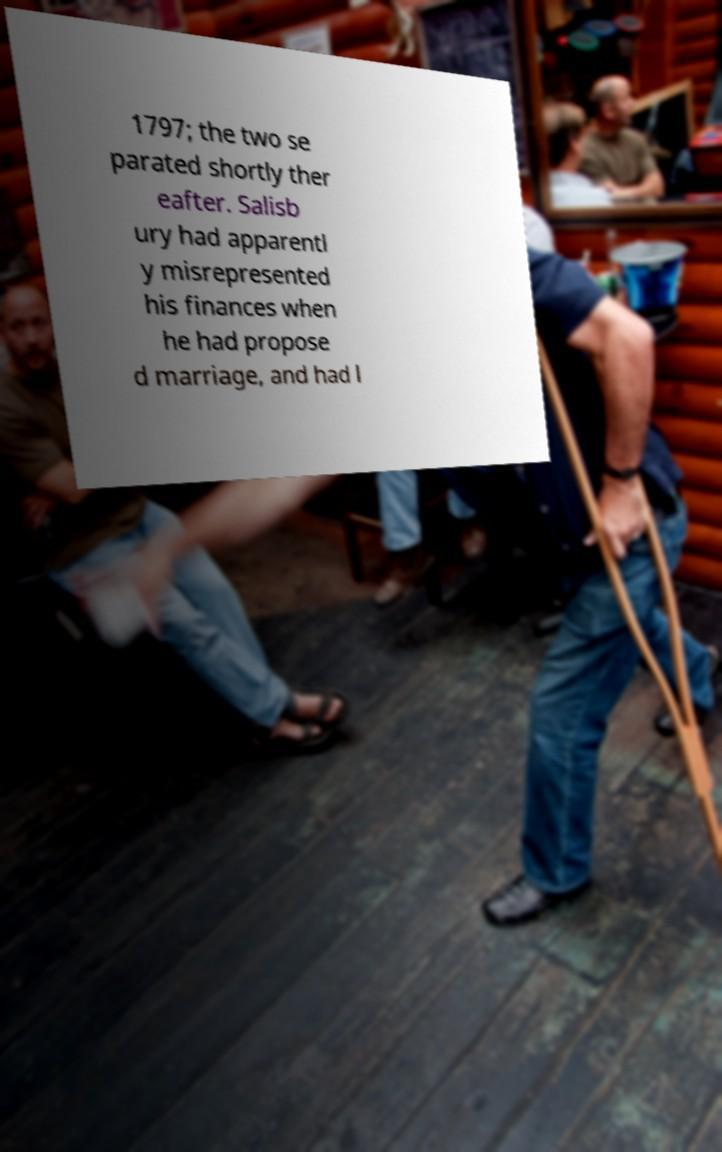For documentation purposes, I need the text within this image transcribed. Could you provide that? 1797; the two se parated shortly ther eafter. Salisb ury had apparentl y misrepresented his finances when he had propose d marriage, and had l 